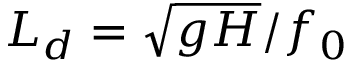<formula> <loc_0><loc_0><loc_500><loc_500>L _ { d } = \sqrt { g H } / f _ { 0 }</formula> 